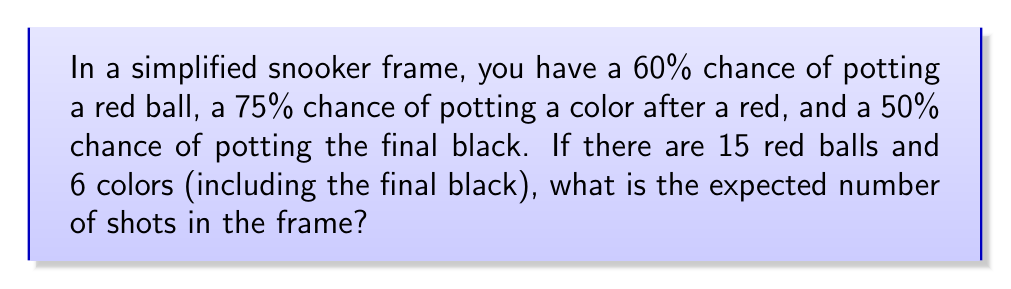Help me with this question. Let's approach this step-by-step using Markov chains:

1) First, we need to define our states:
   State 0: Start of frame
   State 1: After potting a red
   State 2: After potting a color (not final black)
   State 3: Final black
   State 4: End of frame

2) Now, let's define our transition probabilities:
   $$P = \begin{bmatrix}
   0 & 0.6 & 0 & 0 & 0.4 \\
   0 & 0 & 0.75 & 0 & 0.25 \\
   0.6 & 0 & 0 & 0 & 0.4 \\
   0 & 0 & 0 & 0 & 1 \\
   0 & 0 & 0 & 0 & 1
   \end{bmatrix}$$

3) Let $\mu_i$ be the expected number of shots starting from state $i$. We can write:
   $$\mu_0 = 1 + 0.6\mu_1 + 0.4\mu_4$$
   $$\mu_1 = 1 + 0.75\mu_2 + 0.25\mu_4$$
   $$\mu_2 = 1 + 0.6\mu_0 + 0.4\mu_4$$
   $$\mu_3 = 1 + 0.5\mu_4 + 0.5\mu_4 = 1 + \mu_4$$
   $$\mu_4 = 0$$

4) Solving this system of equations:
   $$\mu_2 = 1 + 0.6\mu_0$$
   $$\mu_1 = 1 + 0.75(1 + 0.6\mu_0) = 1.75 + 0.45\mu_0$$
   $$\mu_0 = 1 + 0.6(1.75 + 0.45\mu_0) = 2.05 + 0.27\mu_0$$
   $$0.73\mu_0 = 2.05$$
   $$\mu_0 = 2.808219178$$

5) The expected number of shots for one red-color combination is $\mu_0$.

6) There are 15 red-color combinations and one final black.

7) The expected number of shots for the final black is:
   $$\mu_3 = 1 + \mu_4 = 1$$

8) Therefore, the total expected number of shots is:
   $$15 \cdot 2.808219178 + 1 = 43.12328767$$
Answer: 43.12 shots 